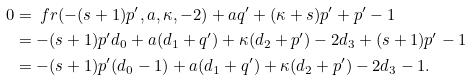<formula> <loc_0><loc_0><loc_500><loc_500>0 & = \ f r ( - ( s + 1 ) p ^ { \prime } , a , \kappa , - 2 ) + a q ^ { \prime } + ( \kappa + s ) p ^ { \prime } + p ^ { \prime } - 1 \\ & = - ( s + 1 ) p ^ { \prime } d _ { 0 } + a ( d _ { 1 } + q ^ { \prime } ) + \kappa ( d _ { 2 } + p ^ { \prime } ) - 2 d _ { 3 } + ( s + 1 ) p ^ { \prime } - 1 \\ & = - ( s + 1 ) p ^ { \prime } ( d _ { 0 } - 1 ) + a ( d _ { 1 } + q ^ { \prime } ) + \kappa ( d _ { 2 } + p ^ { \prime } ) - 2 d _ { 3 } - 1 .</formula> 